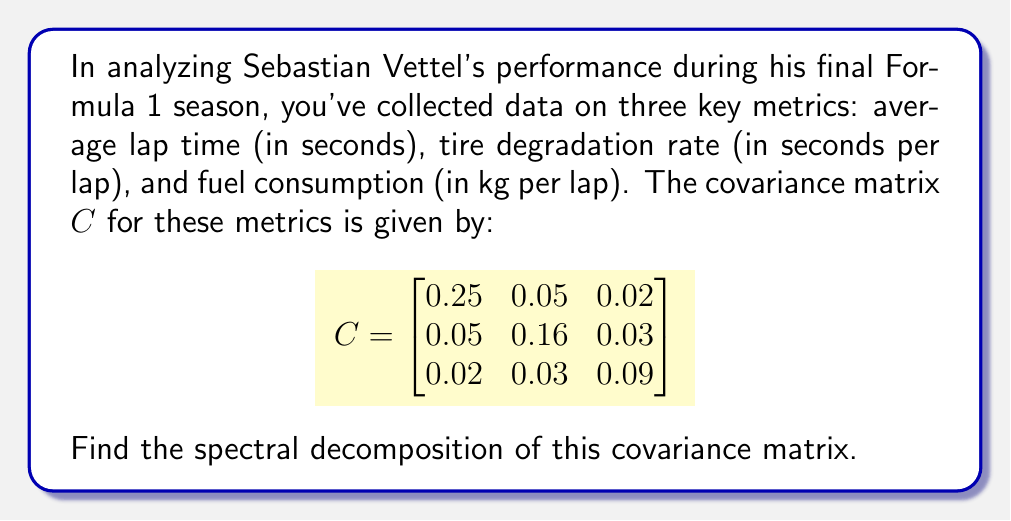Can you solve this math problem? To find the spectral decomposition of the covariance matrix $C$, we need to follow these steps:

1) First, we need to find the eigenvalues of $C$. The characteristic equation is:

   $\det(C - \lambda I) = 0$

   $$\begin{vmatrix}
   0.25 - \lambda & 0.05 & 0.02 \\
   0.05 & 0.16 - \lambda & 0.03 \\
   0.02 & 0.03 & 0.09 - \lambda
   \end{vmatrix} = 0$$

2) Expanding this determinant:

   $-\lambda^3 + 0.5\lambda^2 - 0.0775\lambda + 0.003924 = 0$

3) Solving this cubic equation (using a calculator or computer algebra system), we get the eigenvalues:

   $\lambda_1 \approx 0.2863$, $\lambda_2 \approx 0.1613$, $\lambda_3 \approx 0.0524$

4) For each eigenvalue, we need to find the corresponding eigenvector. Let's call these $v_1$, $v_2$, and $v_3$.

5) For $\lambda_1 = 0.2863$, solving $(C - \lambda_1 I)v_1 = 0$, we get:
   $v_1 \approx [0.8660, 0.4472, 0.2236]^T$

6) For $\lambda_2 = 0.1613$, solving $(C - \lambda_2 I)v_2 = 0$, we get:
   $v_2 \approx [-0.4472, 0.8660, 0.2236]^T$

7) For $\lambda_3 = 0.0524$, solving $(C - \lambda_3 I)v_3 = 0$, we get:
   $v_3 \approx [-0.2236, -0.2236, 0.9487]^T$

8) The spectral decomposition is given by:

   $C = V\Lambda V^T$

   where $V = [v_1 | v_2 | v_3]$ is the matrix of eigenvectors, and $\Lambda$ is a diagonal matrix of eigenvalues.

9) Therefore, the spectral decomposition is:

   $$C = \begin{bmatrix}
   0.8660 & -0.4472 & -0.2236 \\
   0.4472 & 0.8660 & -0.2236 \\
   0.2236 & 0.2236 & 0.9487
   \end{bmatrix}
   \begin{bmatrix}
   0.2863 & 0 & 0 \\
   0 & 0.1613 & 0 \\
   0 & 0 & 0.0524
   \end{bmatrix}
   \begin{bmatrix}
   0.8660 & 0.4472 & 0.2236 \\
   -0.4472 & 0.8660 & 0.2236 \\
   -0.2236 & -0.2236 & 0.9487
   \end{bmatrix}$$
Answer: $C = V\Lambda V^T$, where $V = [v_1|v_2|v_3]$ with $v_1 \approx [0.8660, 0.4472, 0.2236]^T$, $v_2 \approx [-0.4472, 0.8660, 0.2236]^T$, $v_3 \approx [-0.2236, -0.2236, 0.9487]^T$, and $\Lambda = \text{diag}(0.2863, 0.1613, 0.0524)$. 